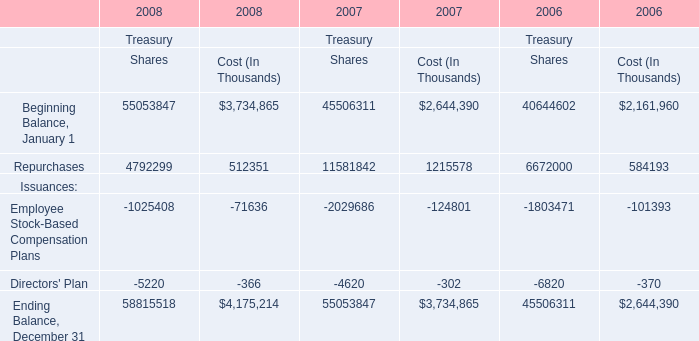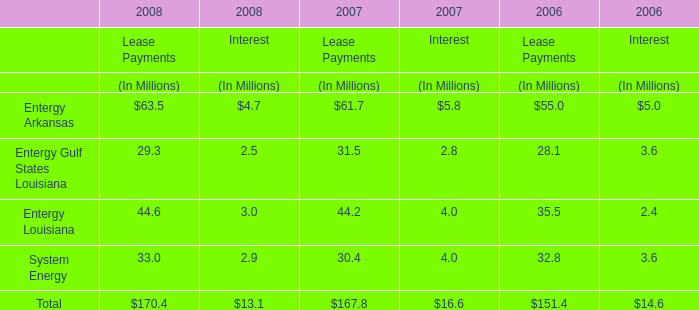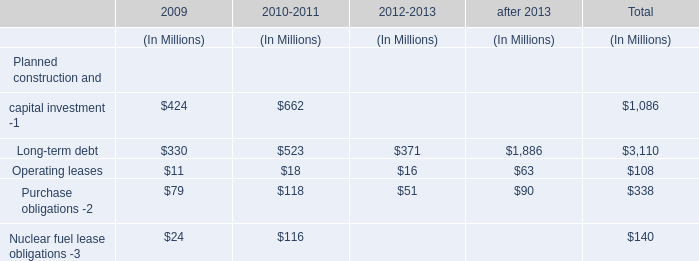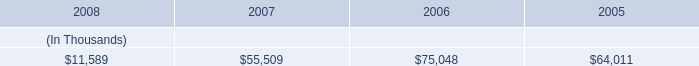In the year with largest amount of Repurchases for Cost, what's the sum of elements for Cost? (in Thousand) 
Computations: (((2644390 + 1215578) - 124801) - 302)
Answer: 3734865.0. 